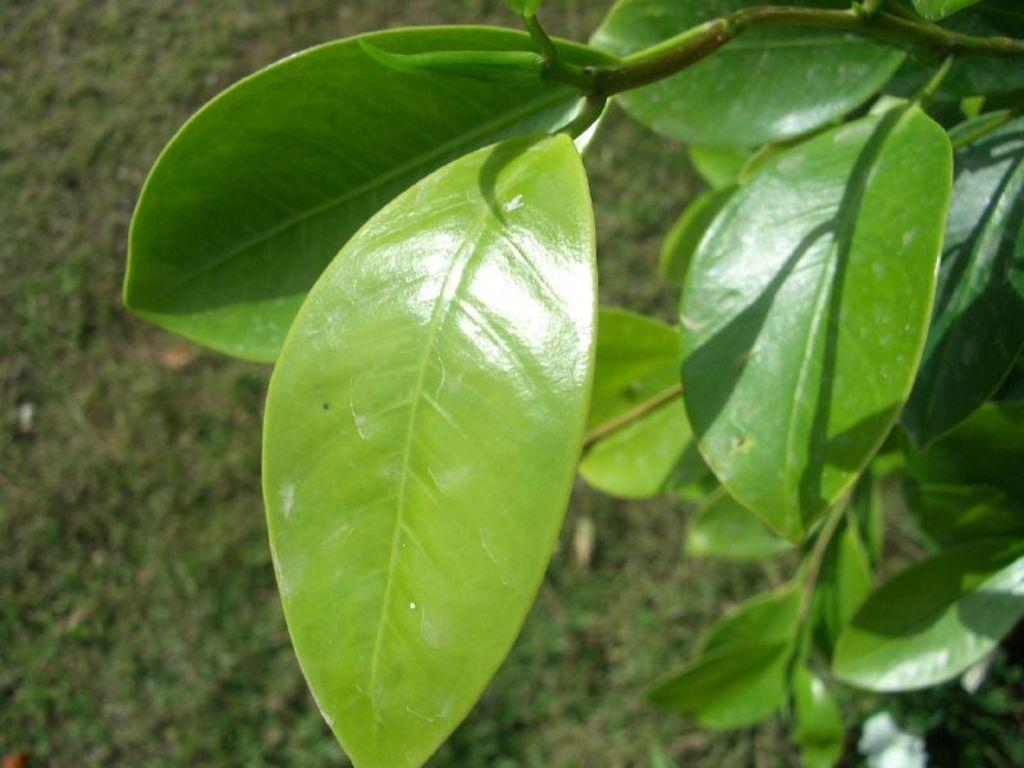What color are the leaves in the image? The leaves in the image are green. Can you describe the background of the image? The background of the image is blurred. How many men are helping in the image? There are no men present in the image, and no help is being provided. 